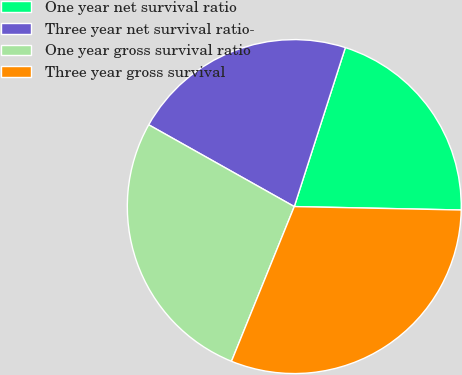<chart> <loc_0><loc_0><loc_500><loc_500><pie_chart><fcel>One year net survival ratio<fcel>Three year net survival ratio-<fcel>One year gross survival ratio<fcel>Three year gross survival<nl><fcel>20.38%<fcel>21.8%<fcel>27.01%<fcel>30.81%<nl></chart> 